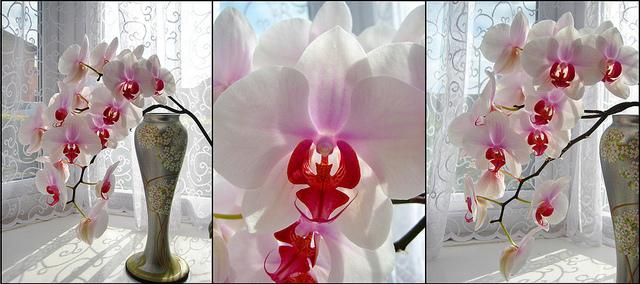What color are the flowers?
Quick response, please. White and pink. What kind of flower is this?
Be succinct. Orchid. How many pictures make up this photo?
Answer briefly. 3. 